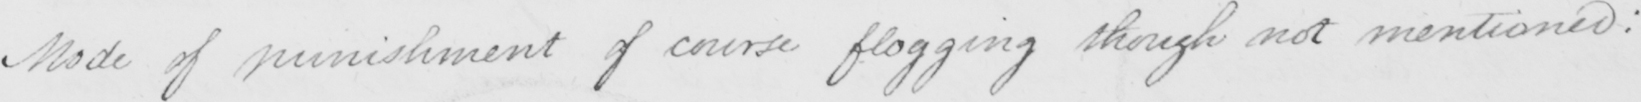Please provide the text content of this handwritten line. Mode of punishment of course flogging though not mentioned : 